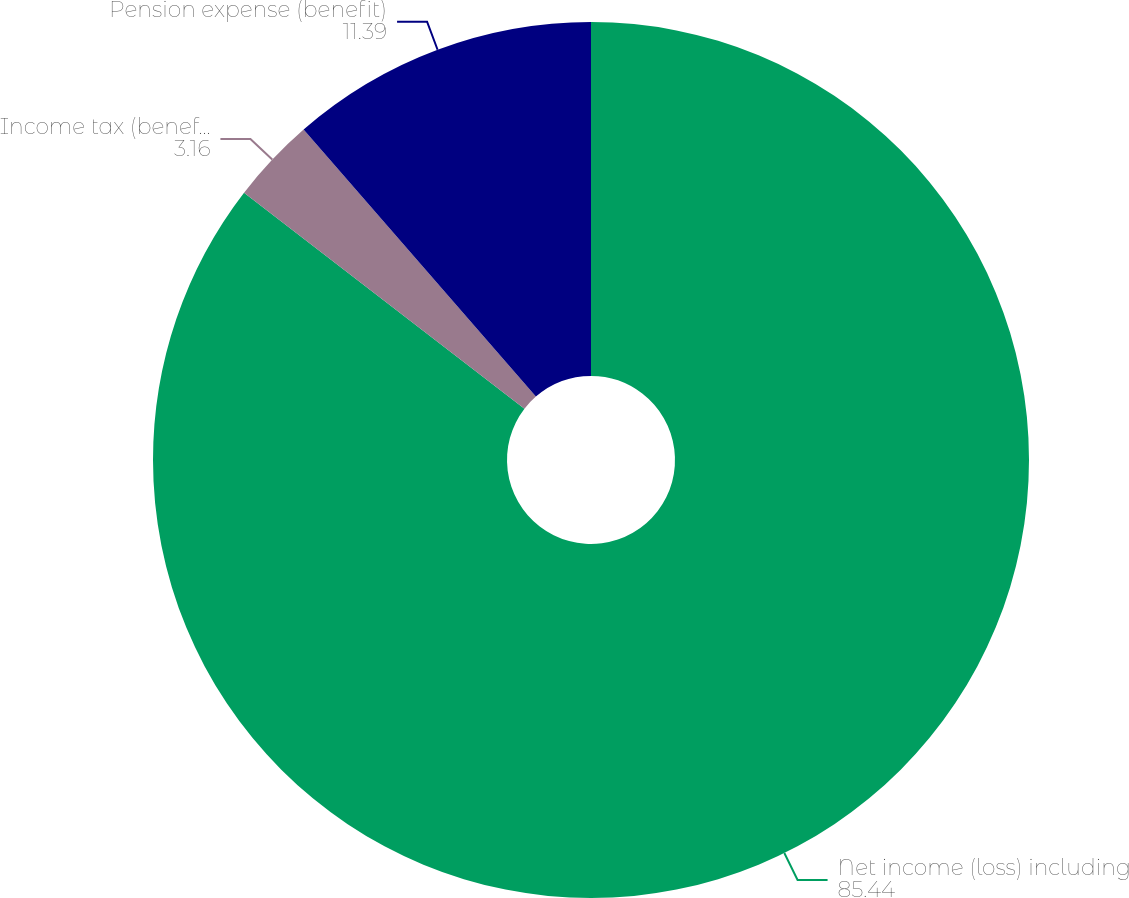Convert chart to OTSL. <chart><loc_0><loc_0><loc_500><loc_500><pie_chart><fcel>Net income (loss) including<fcel>Income tax (benefit) expense<fcel>Pension expense (benefit)<nl><fcel>85.44%<fcel>3.16%<fcel>11.39%<nl></chart> 